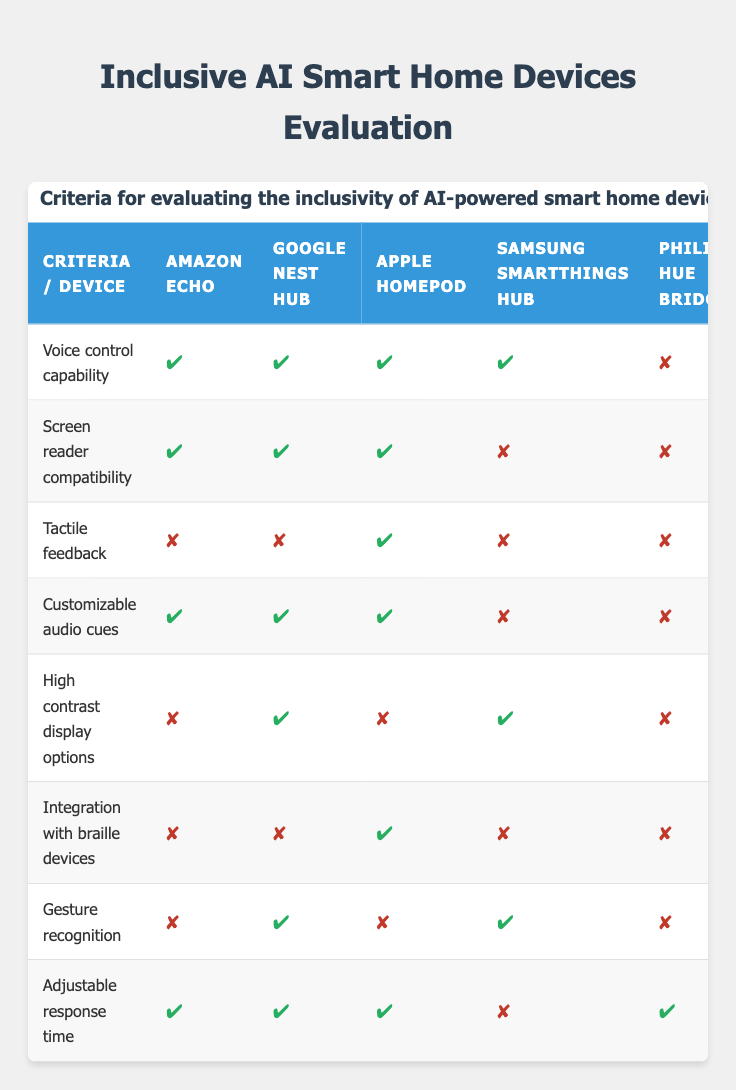What devices have voice control capability? From the table, it can be seen that Amazon Echo, Google Nest Hub, Apple HomePod, and Samsung SmartThings Hub all have voice control capabilities, indicated by the checkmarks. The only device without this feature is Philips Hue Bridge, which has a cross.
Answer: Amazon Echo, Google Nest Hub, Apple HomePod, Samsung SmartThings Hub How many devices have screen reader compatibility? By reviewing the table, Amazon Echo, Google Nest Hub, and Apple HomePod all have screen reader compatibility, while Samsung SmartThings Hub and Philips Hue Bridge do not. This gives us a total of three devices with this feature.
Answer: 3 Which device has tactile feedback? Looking at the table, only Apple HomePod has tactile feedback, as indicated by the checkmark. The other devices (Amazon Echo, Google Nest Hub, Samsung SmartThings Hub, Philips Hue Bridge) do not offer this feature.
Answer: Apple HomePod Is customizable audio cues available in all devices? The table shows that customizable audio cues are available in Amazon Echo, Google Nest Hub, and Apple HomePod. However, both Samsung SmartThings Hub and Philips Hue Bridge lack this feature, indicated by the crosses. Therefore, the answer is no, it is not available in all devices.
Answer: No Which device has the highest number of features marked as 'true'? To answer this, we need to count the 'true' attributes for each device: Amazon Echo has 5, Google Nest Hub has 6, Apple HomePod has 6, Samsung SmartThings Hub has 3, and Philips Hue Bridge has 1. Google Nest Hub and Apple HomePod have the highest number of features marked as 'true', both with 6 features.
Answer: Google Nest Hub, Apple HomePod How many devices do not have gesture recognition? By examining the table, it can be seen that Amazon Echo, Apple HomePod, and Philips Hue Bridge do not support gesture recognition (marked with a cross). Thus, there are three devices without this feature.
Answer: 3 What percentage of devices support braille integration? Out of the 5 devices listed, only Apple HomePod supports braille integration. To find the percentage, divide the number of devices with braille integration (1) by the total number of devices (5) and multiply by 100. (1/5) * 100 = 20%.
Answer: 20% Which device has both high contrast display options and adjustable response time? From the table, Google Nest Hub and Apple HomePod have high contrast display options as well as adjustable response time, shown by their checkmarks. Therefore, the answer is these two devices.
Answer: Google Nest Hub, Apple HomePod 